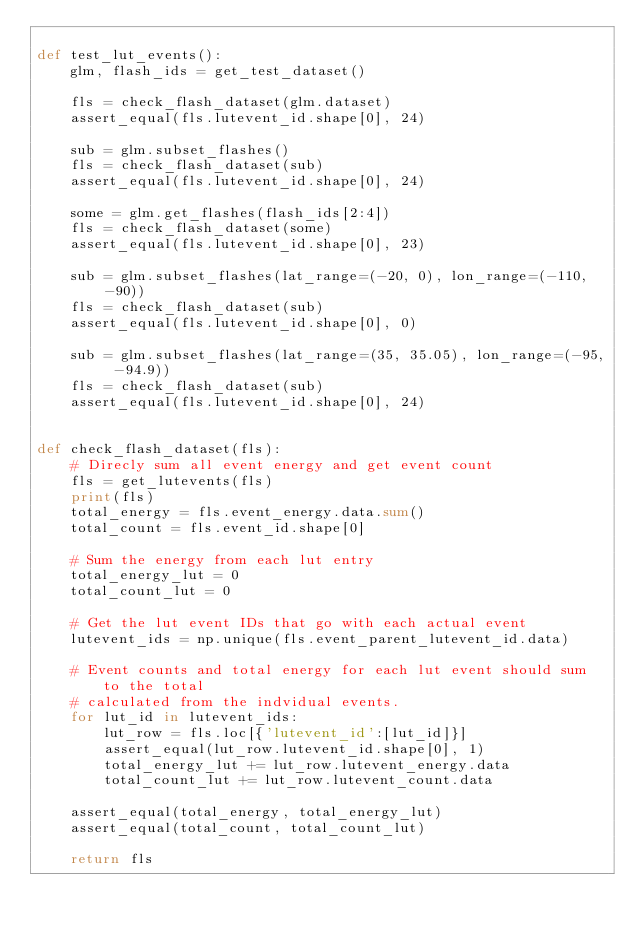<code> <loc_0><loc_0><loc_500><loc_500><_Python_>
def test_lut_events():
    glm, flash_ids = get_test_dataset()
    
    fls = check_flash_dataset(glm.dataset)
    assert_equal(fls.lutevent_id.shape[0], 24)

    sub = glm.subset_flashes()
    fls = check_flash_dataset(sub)
    assert_equal(fls.lutevent_id.shape[0], 24)

    some = glm.get_flashes(flash_ids[2:4])
    fls = check_flash_dataset(some)
    assert_equal(fls.lutevent_id.shape[0], 23)

    sub = glm.subset_flashes(lat_range=(-20, 0), lon_range=(-110, -90))
    fls = check_flash_dataset(sub)
    assert_equal(fls.lutevent_id.shape[0], 0)

    sub = glm.subset_flashes(lat_range=(35, 35.05), lon_range=(-95, -94.9))
    fls = check_flash_dataset(sub)
    assert_equal(fls.lutevent_id.shape[0], 24)


def check_flash_dataset(fls):
    # Direcly sum all event energy and get event count
    fls = get_lutevents(fls)
    print(fls)
    total_energy = fls.event_energy.data.sum()
    total_count = fls.event_id.shape[0]

    # Sum the energy from each lut entry
    total_energy_lut = 0
    total_count_lut = 0

    # Get the lut event IDs that go with each actual event
    lutevent_ids = np.unique(fls.event_parent_lutevent_id.data)

    # Event counts and total energy for each lut event should sum to the total
    # calculated from the indvidual events.
    for lut_id in lutevent_ids:
        lut_row = fls.loc[{'lutevent_id':[lut_id]}]
        assert_equal(lut_row.lutevent_id.shape[0], 1)
        total_energy_lut += lut_row.lutevent_energy.data
        total_count_lut += lut_row.lutevent_count.data
    
    assert_equal(total_energy, total_energy_lut)
    assert_equal(total_count, total_count_lut)
    
    return fls
        
    
    
    </code> 